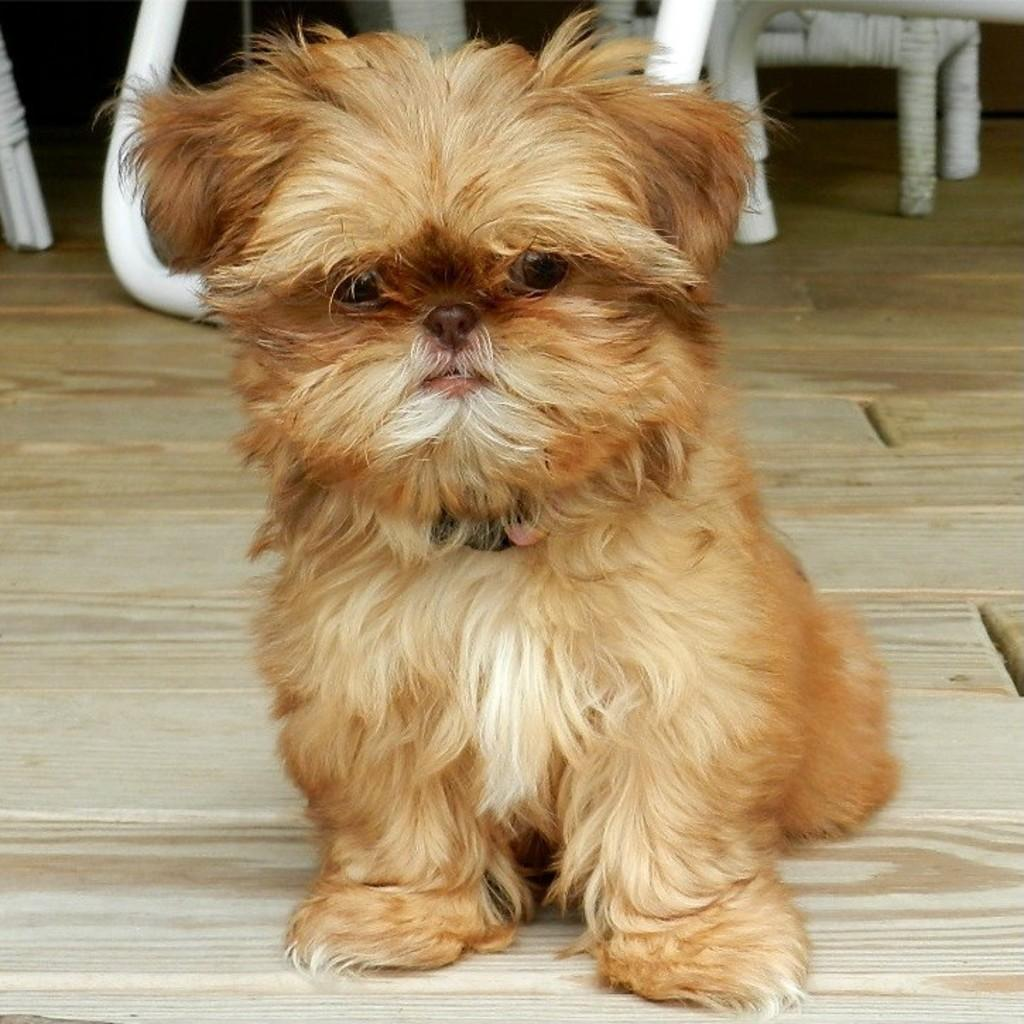What type of animal is in the image? There is a dog in the image. Where is the dog located in the image? The dog is on the floor. What can be seen in the background of the image? There are objects visible in the background of the image. What type of wire is the dog chewing on in the image? There is no wire present in the image; the dog is on the floor without any visible objects in its mouth. 